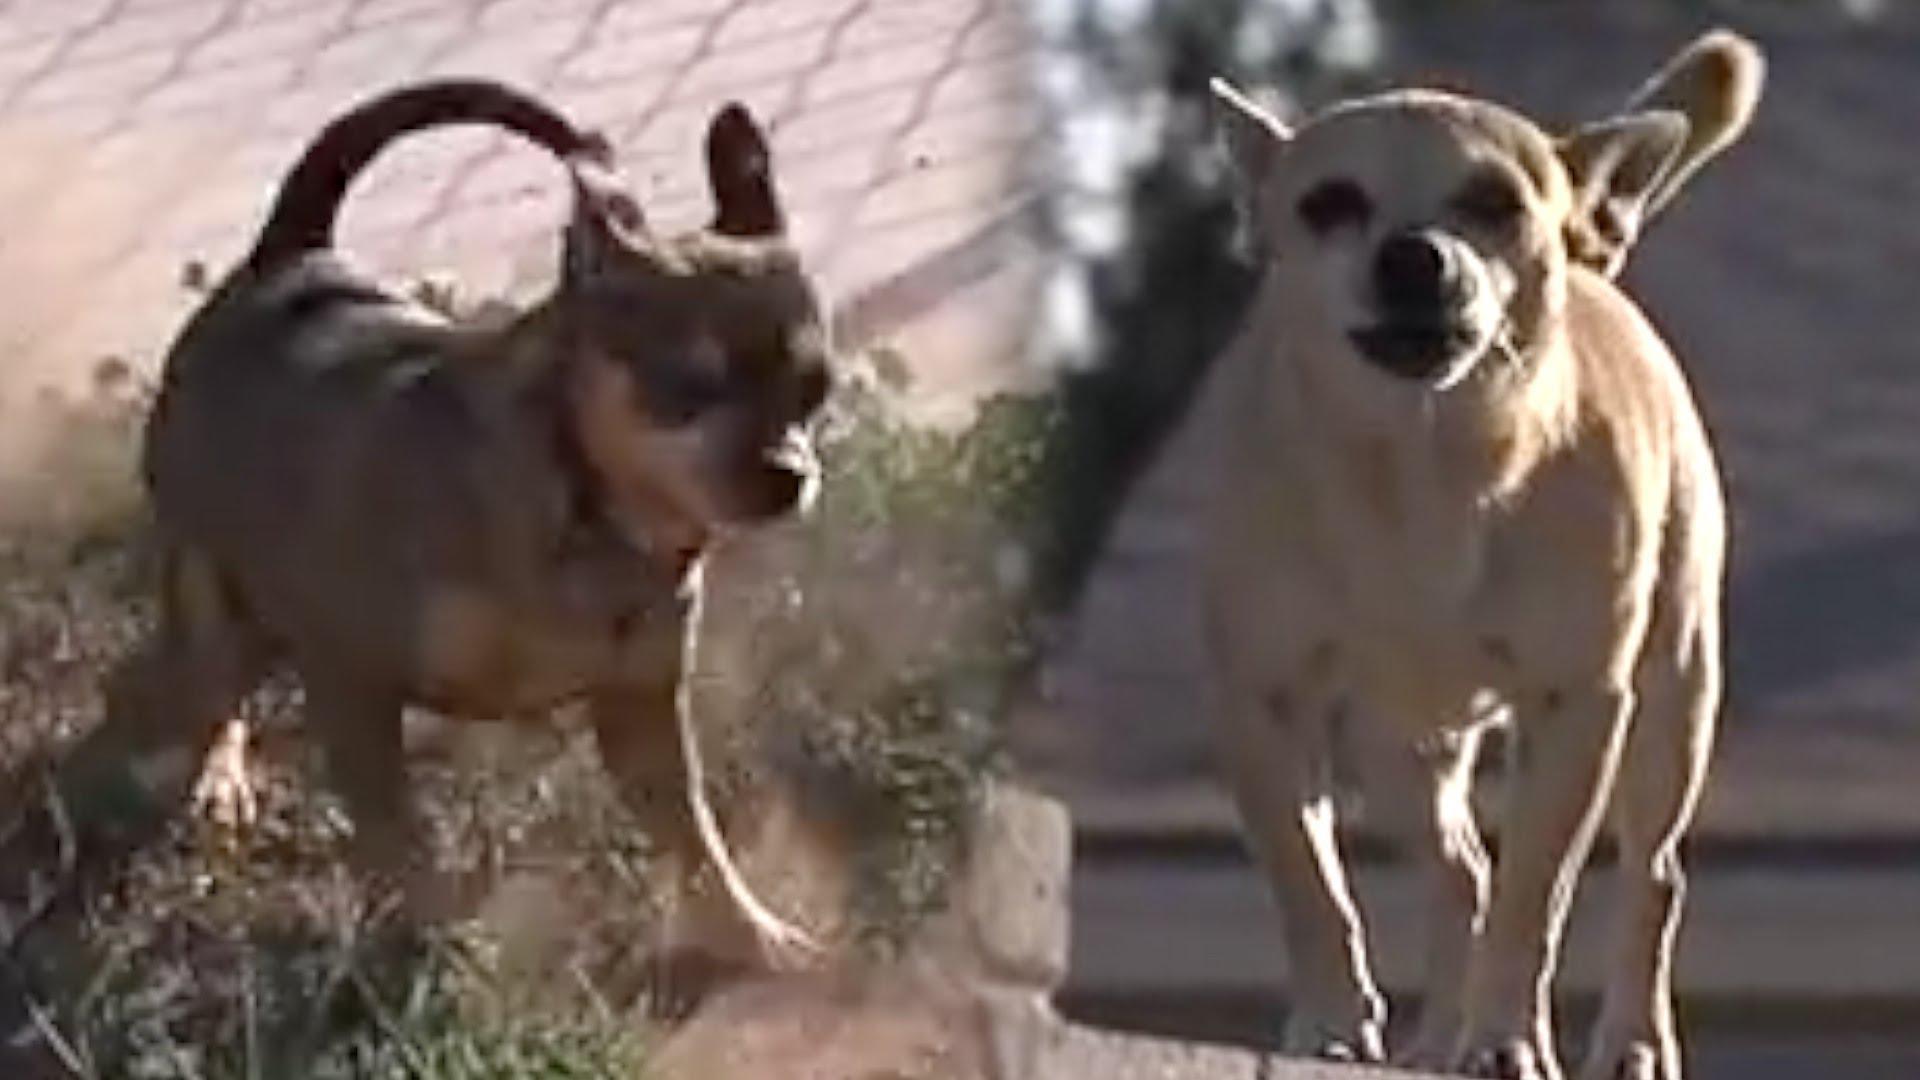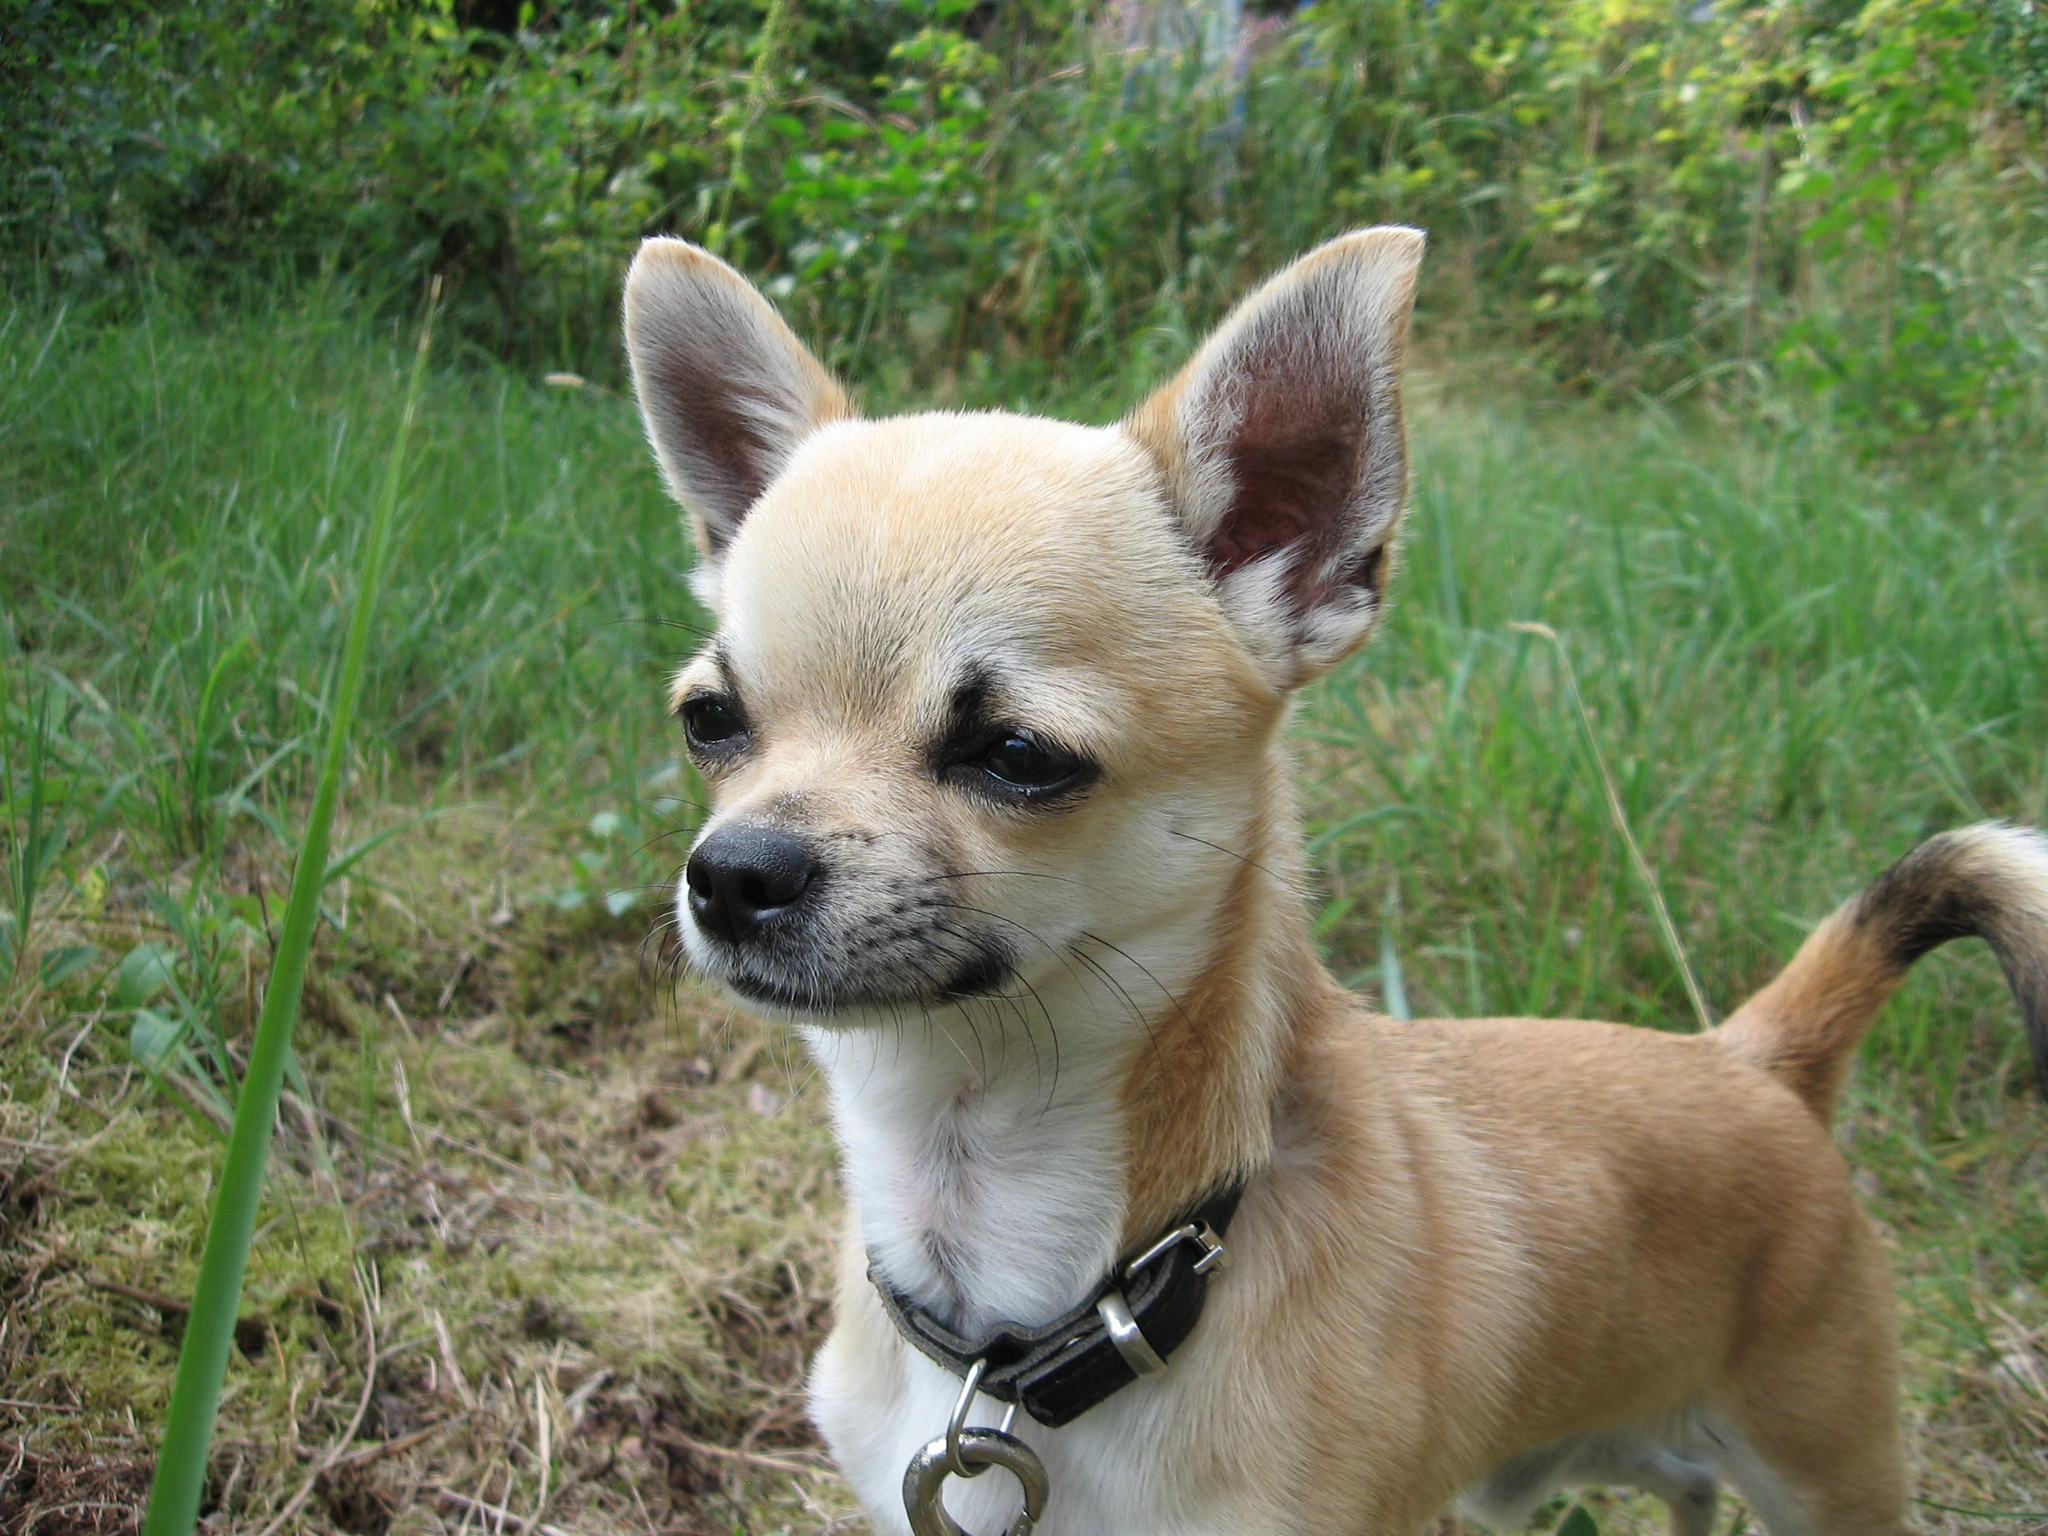The first image is the image on the left, the second image is the image on the right. Examine the images to the left and right. Is the description "The right image contains at least two chihuahua's." accurate? Answer yes or no. No. The first image is the image on the left, the second image is the image on the right. For the images shown, is this caption "There are three dogs shown" true? Answer yes or no. Yes. 